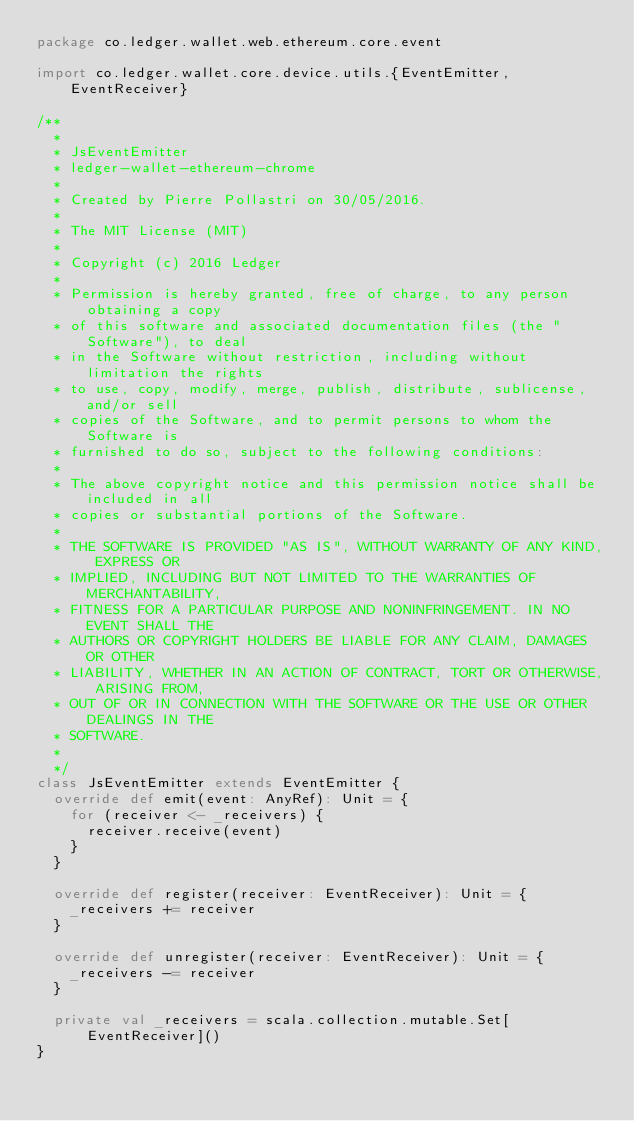Convert code to text. <code><loc_0><loc_0><loc_500><loc_500><_Scala_>package co.ledger.wallet.web.ethereum.core.event

import co.ledger.wallet.core.device.utils.{EventEmitter, EventReceiver}

/**
  *
  * JsEventEmitter
  * ledger-wallet-ethereum-chrome
  *
  * Created by Pierre Pollastri on 30/05/2016.
  *
  * The MIT License (MIT)
  *
  * Copyright (c) 2016 Ledger
  *
  * Permission is hereby granted, free of charge, to any person obtaining a copy
  * of this software and associated documentation files (the "Software"), to deal
  * in the Software without restriction, including without limitation the rights
  * to use, copy, modify, merge, publish, distribute, sublicense, and/or sell
  * copies of the Software, and to permit persons to whom the Software is
  * furnished to do so, subject to the following conditions:
  *
  * The above copyright notice and this permission notice shall be included in all
  * copies or substantial portions of the Software.
  *
  * THE SOFTWARE IS PROVIDED "AS IS", WITHOUT WARRANTY OF ANY KIND, EXPRESS OR
  * IMPLIED, INCLUDING BUT NOT LIMITED TO THE WARRANTIES OF MERCHANTABILITY,
  * FITNESS FOR A PARTICULAR PURPOSE AND NONINFRINGEMENT. IN NO EVENT SHALL THE
  * AUTHORS OR COPYRIGHT HOLDERS BE LIABLE FOR ANY CLAIM, DAMAGES OR OTHER
  * LIABILITY, WHETHER IN AN ACTION OF CONTRACT, TORT OR OTHERWISE, ARISING FROM,
  * OUT OF OR IN CONNECTION WITH THE SOFTWARE OR THE USE OR OTHER DEALINGS IN THE
  * SOFTWARE.
  *
  */
class JsEventEmitter extends EventEmitter {
  override def emit(event: AnyRef): Unit = {
    for (receiver <- _receivers) {
      receiver.receive(event)
    }
  }

  override def register(receiver: EventReceiver): Unit = {
    _receivers += receiver
  }

  override def unregister(receiver: EventReceiver): Unit = {
    _receivers -= receiver
  }

  private val _receivers = scala.collection.mutable.Set[EventReceiver]()
}
</code> 